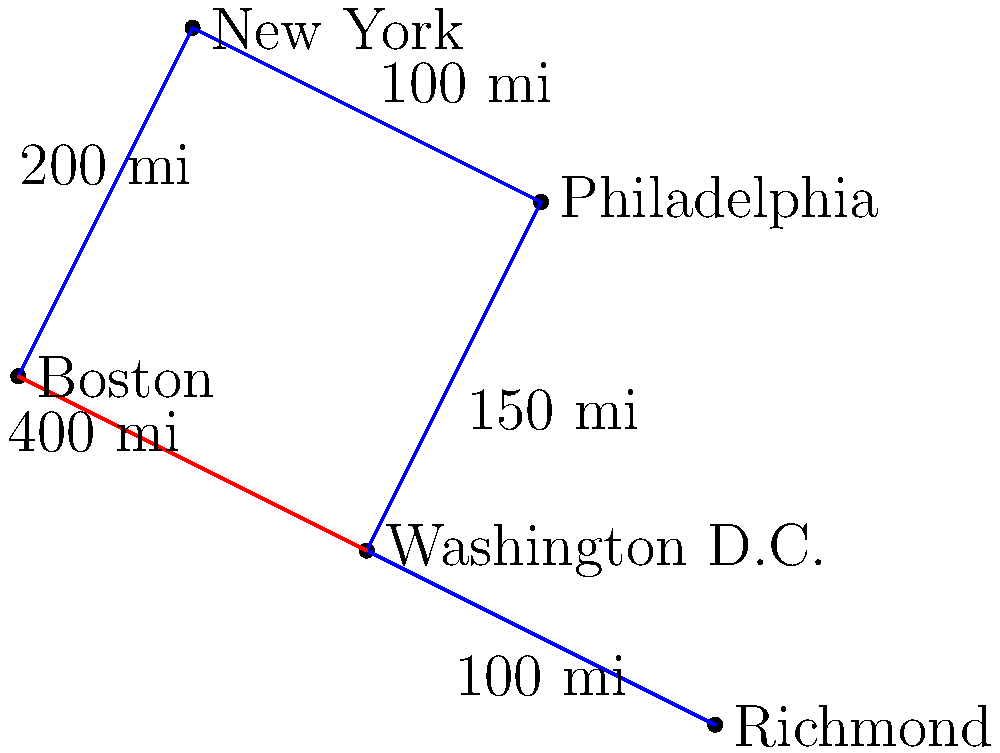James Taylor is planning his upcoming East Coast tour. The map shows five major cities and the distances between them. What is the shortest route from Boston to Richmond, and how many miles will James Taylor travel? Let's approach this step-by-step:

1. We have two possible routes from Boston to Richmond:
   a) Boston -> New York -> Philadelphia -> Washington D.C. -> Richmond
   b) Boston -> Washington D.C. -> Richmond

2. Let's calculate the distance for route (a):
   Boston to New York: 200 miles
   New York to Philadelphia: 100 miles
   Philadelphia to Washington D.C.: 150 miles
   Washington D.C. to Richmond: 100 miles
   Total: $200 + 100 + 150 + 100 = 550$ miles

3. Now, let's calculate the distance for route (b):
   Boston to Washington D.C.: 400 miles
   Washington D.C. to Richmond: 100 miles
   Total: $400 + 100 = 500$ miles

4. Comparing the two routes:
   Route (a): 550 miles
   Route (b): 500 miles

5. The shortest route is (b), Boston -> Washington D.C. -> Richmond, with a total distance of 500 miles.
Answer: Boston -> Washington D.C. -> Richmond, 500 miles 